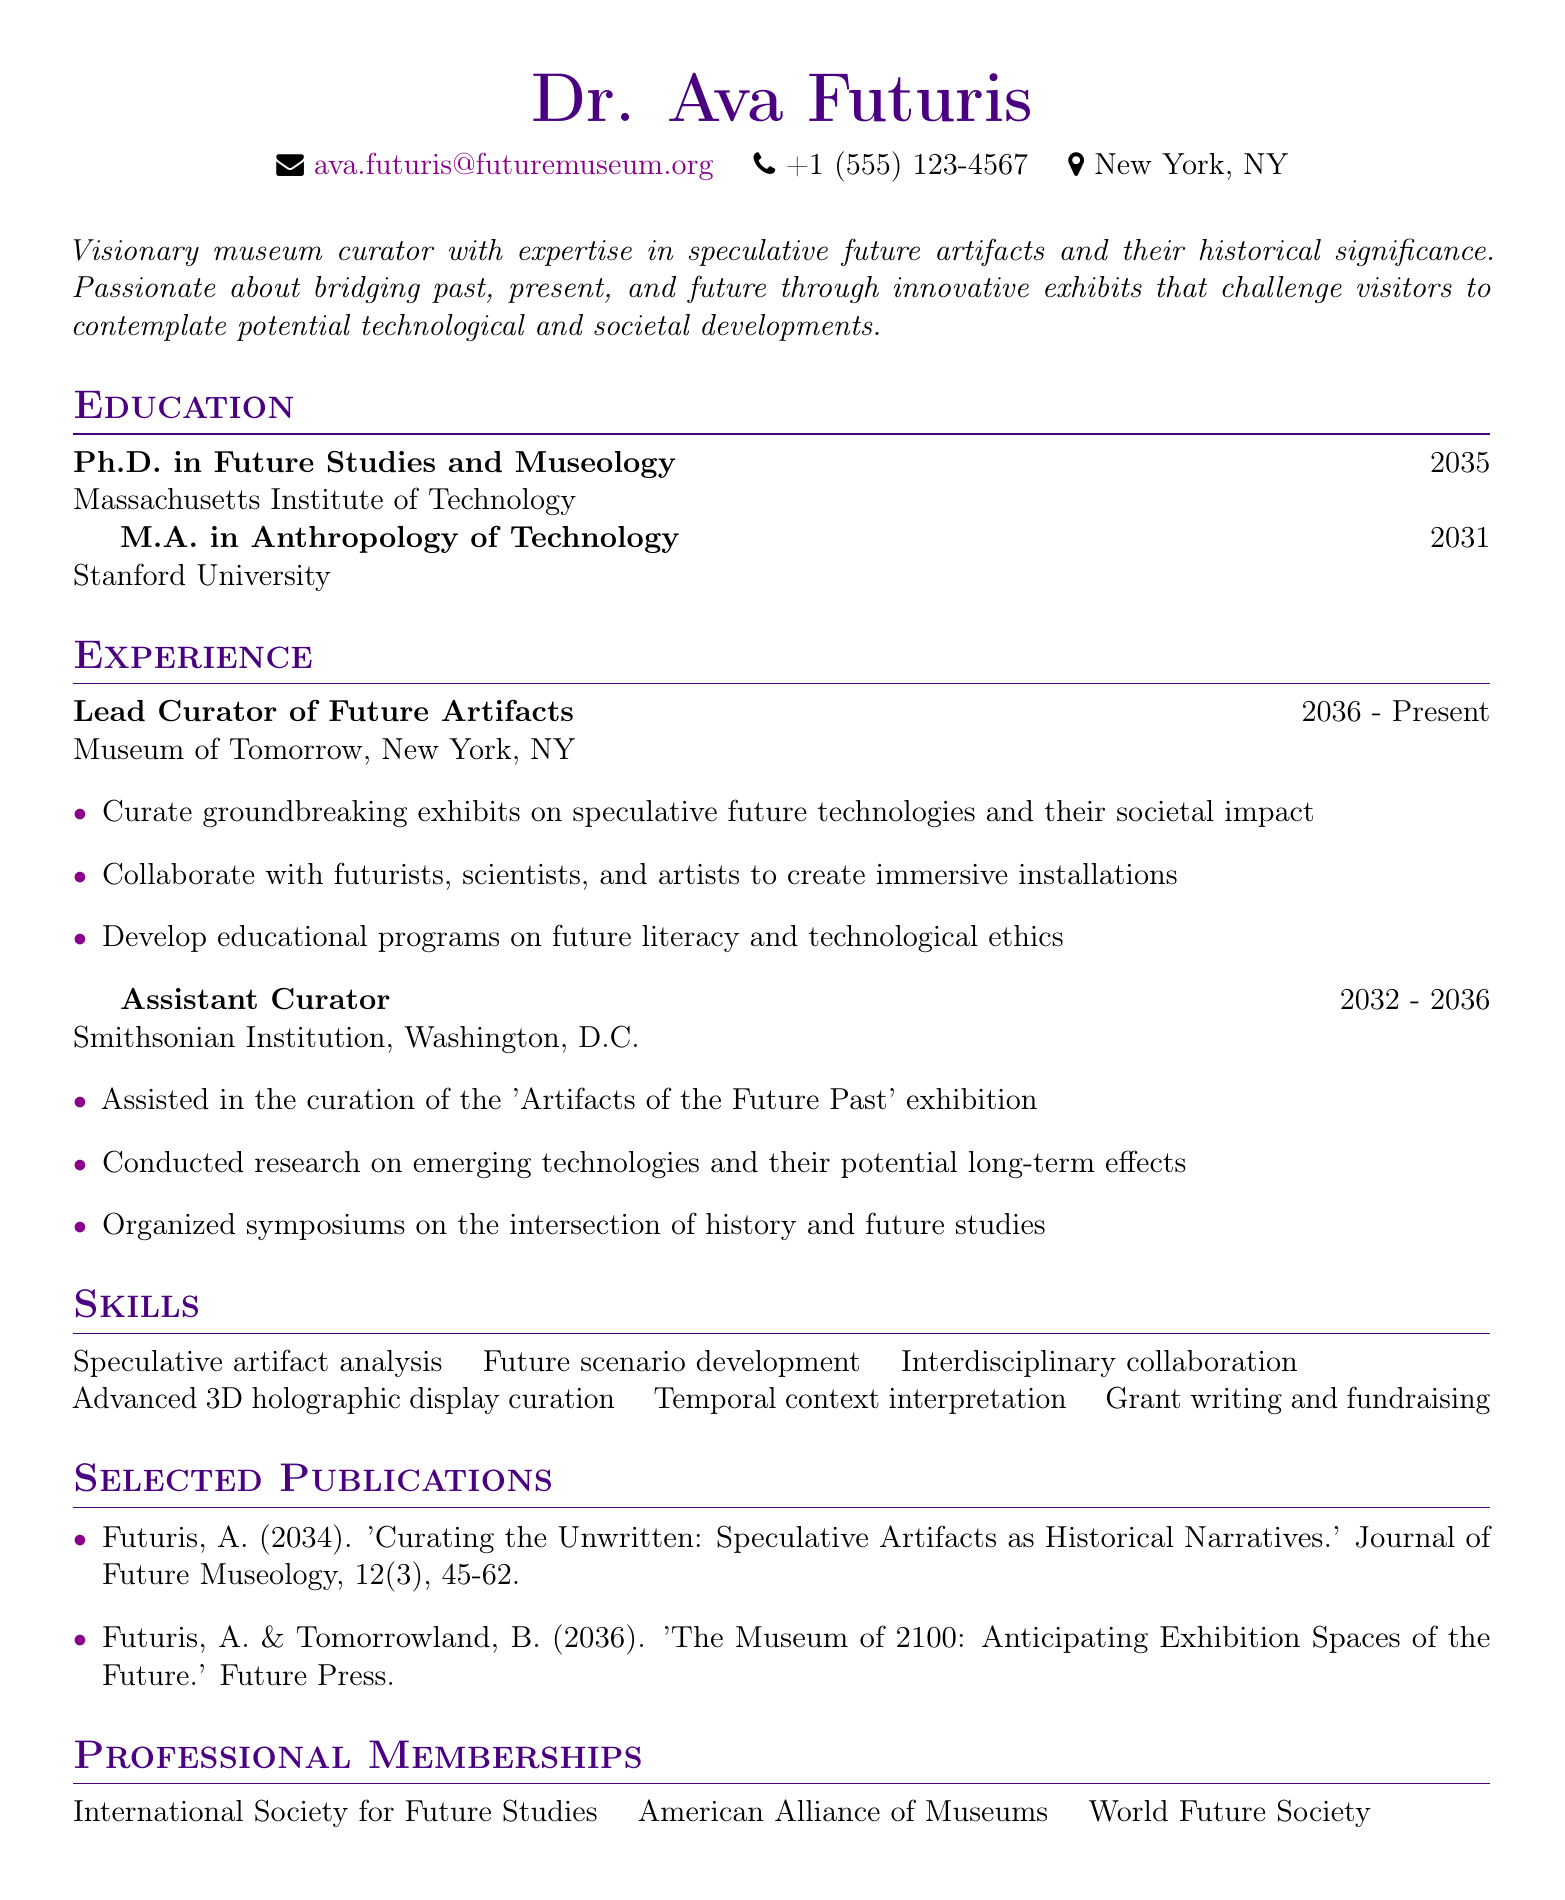What is the name of the curator? The name of the curator is mentioned at the top of the document.
Answer: Dr. Ava Futuris In which city is the curator located? The city is specified in the personal info section of the resume.
Answer: New York, NY What year did Dr. Ava Futuris obtain her Ph.D.? The year is listed in the education section next to the Ph.D. degree.
Answer: 2035 Which organization is Dr. Ava Futuris currently working for? The current organization is mentioned in the experience section under the lead curator position.
Answer: Museum of Tomorrow What is one of the responsibilities of the lead curator? The responsibilities for this position are listed in bullet points under the experience section.
Answer: Curate groundbreaking exhibits on speculative future technologies and their societal impact Which degree did Dr. Ava Futuris earn at Stanford University? The degree is listed in the education section of the resume.
Answer: M.A. in Anthropology of Technology How many publications are listed in the document? The number of publications can be determined by counting the items in the selected publications section.
Answer: 2 What is one of the skills mentioned in the resume? The skills are listed in a row in the skills section of the document.
Answer: Speculative artifact analysis What type of professional memberships does Dr. Ava Futuris hold? The memberships are presented in the professional memberships section.
Answer: International Society for Future Studies 